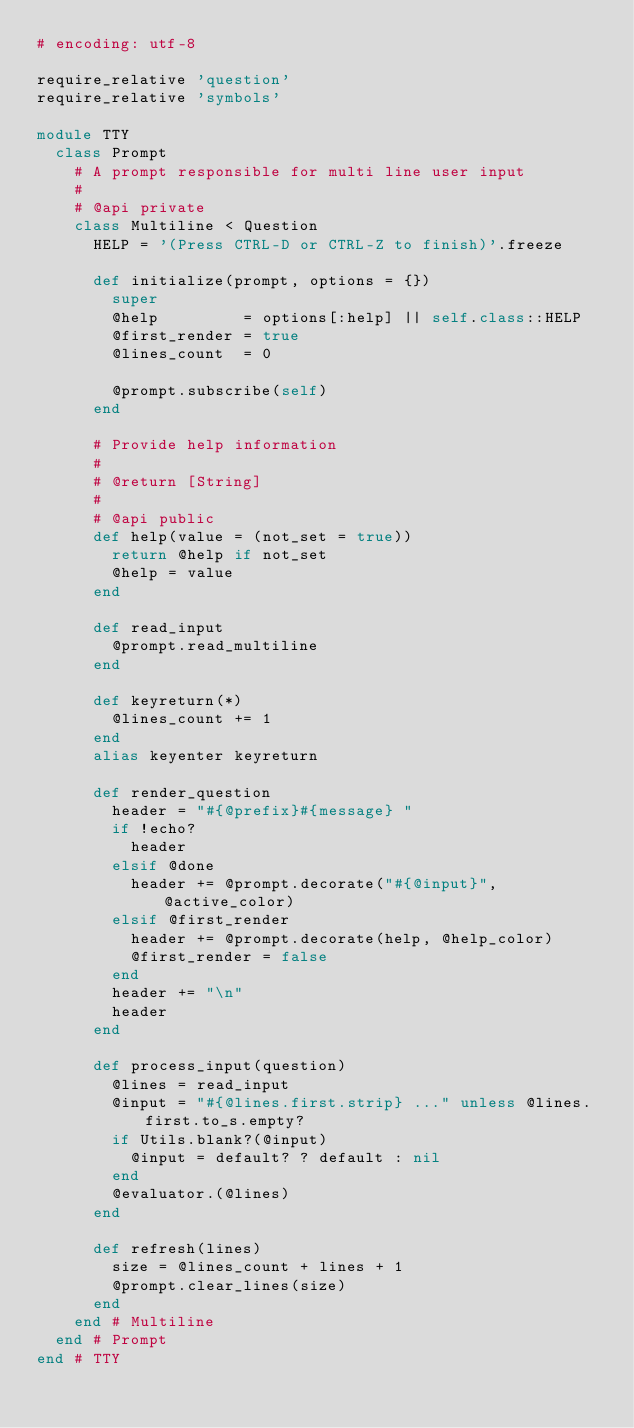<code> <loc_0><loc_0><loc_500><loc_500><_Ruby_># encoding: utf-8

require_relative 'question'
require_relative 'symbols'

module TTY
  class Prompt
    # A prompt responsible for multi line user input
    #
    # @api private
    class Multiline < Question
      HELP = '(Press CTRL-D or CTRL-Z to finish)'.freeze

      def initialize(prompt, options = {})
        super
        @help         = options[:help] || self.class::HELP
        @first_render = true
        @lines_count  = 0

        @prompt.subscribe(self)
      end

      # Provide help information
      #
      # @return [String]
      #
      # @api public
      def help(value = (not_set = true))
        return @help if not_set
        @help = value
      end

      def read_input
        @prompt.read_multiline
      end

      def keyreturn(*)
        @lines_count += 1
      end
      alias keyenter keyreturn

      def render_question
        header = "#{@prefix}#{message} "
        if !echo?
          header
        elsif @done
          header += @prompt.decorate("#{@input}", @active_color)
        elsif @first_render
          header += @prompt.decorate(help, @help_color)
          @first_render = false
        end
        header += "\n"
        header
      end

      def process_input(question)
        @lines = read_input
        @input = "#{@lines.first.strip} ..." unless @lines.first.to_s.empty?
        if Utils.blank?(@input)
          @input = default? ? default : nil
        end
        @evaluator.(@lines)
      end

      def refresh(lines)
        size = @lines_count + lines + 1
        @prompt.clear_lines(size)
      end
    end # Multiline
  end # Prompt
end # TTY
</code> 